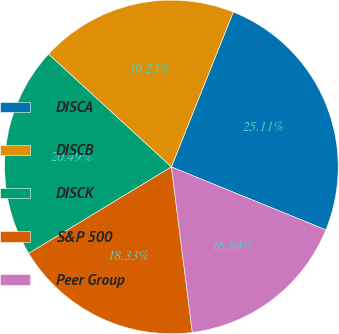<chart> <loc_0><loc_0><loc_500><loc_500><pie_chart><fcel>DISCA<fcel>DISCB<fcel>DISCK<fcel>S&P 500<fcel>Peer Group<nl><fcel>25.11%<fcel>19.23%<fcel>20.49%<fcel>18.33%<fcel>16.84%<nl></chart> 